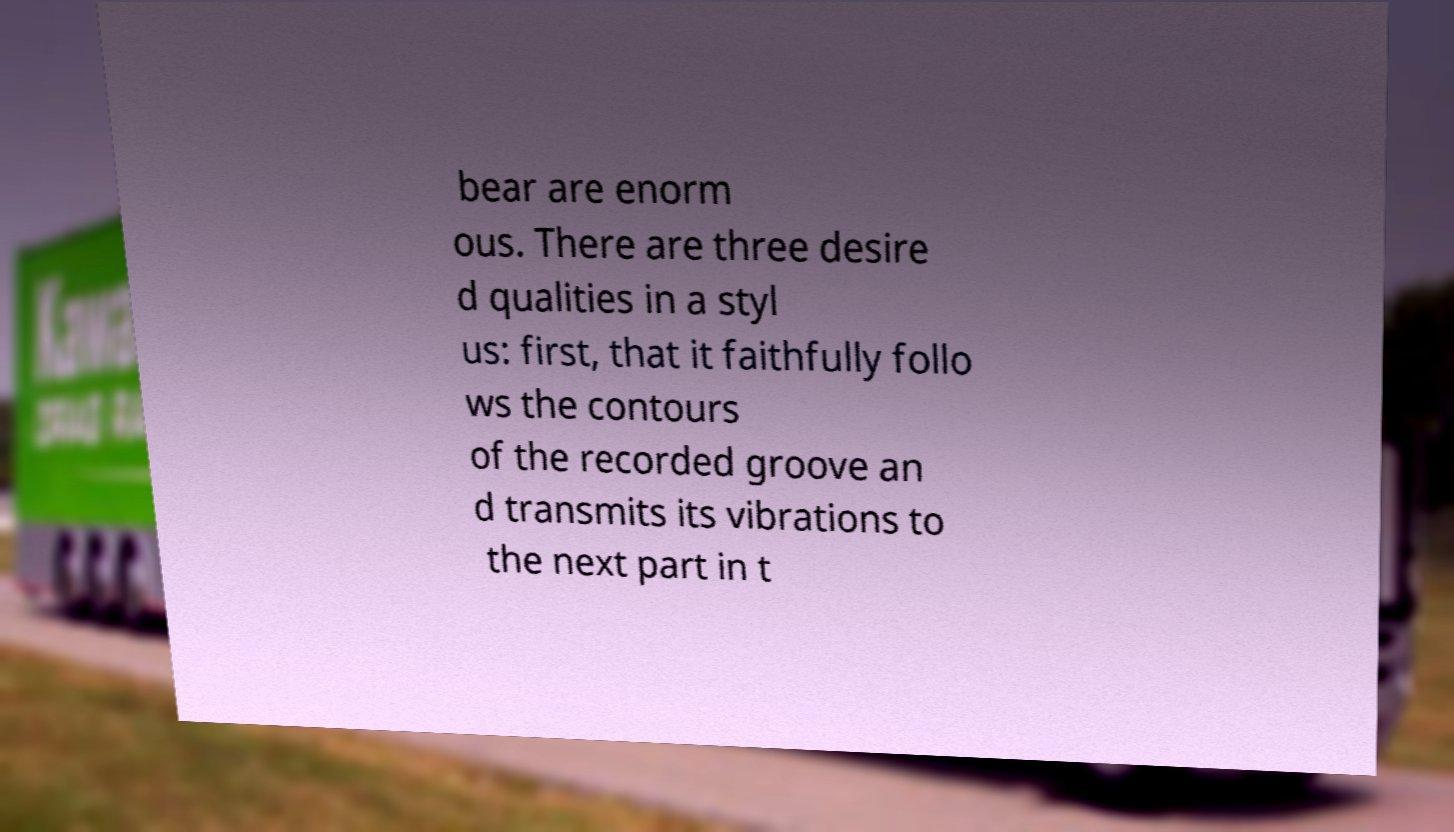Could you assist in decoding the text presented in this image and type it out clearly? bear are enorm ous. There are three desire d qualities in a styl us: first, that it faithfully follo ws the contours of the recorded groove an d transmits its vibrations to the next part in t 